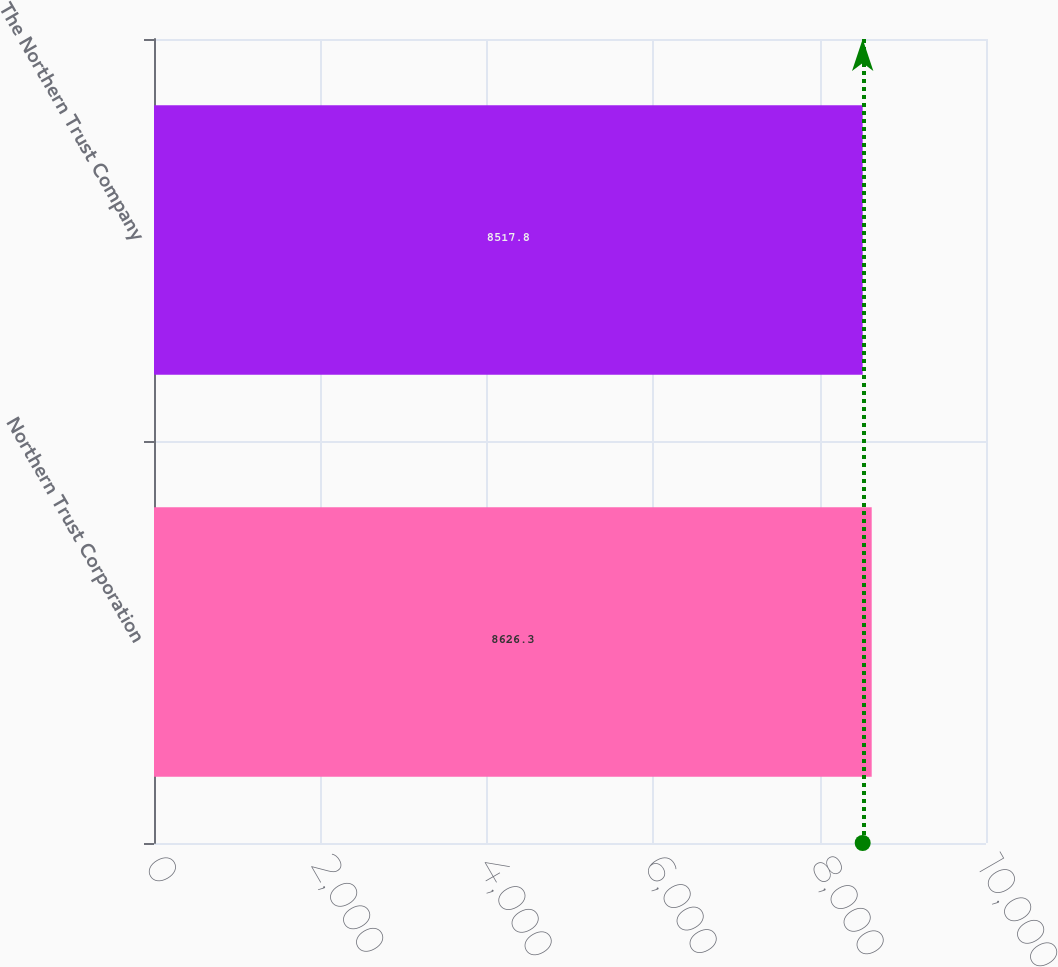Convert chart. <chart><loc_0><loc_0><loc_500><loc_500><bar_chart><fcel>Northern Trust Corporation<fcel>The Northern Trust Company<nl><fcel>8626.3<fcel>8517.8<nl></chart> 